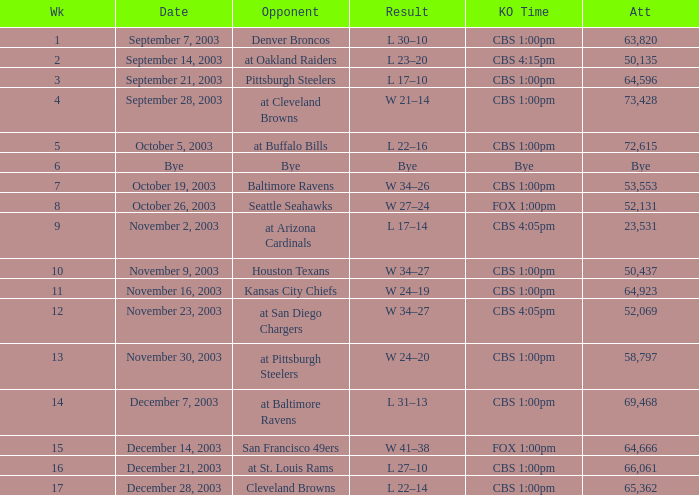What was the kickoff time on week 1? CBS 1:00pm. 